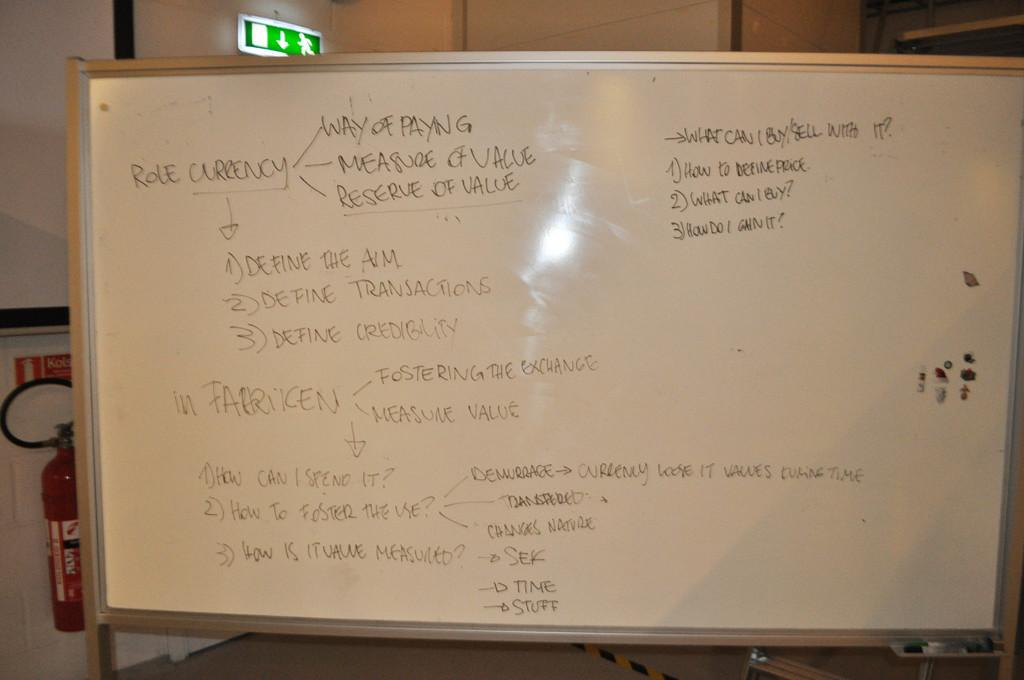<image>
Create a compact narrative representing the image presented. a white board with role currency explained on it 